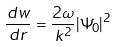<formula> <loc_0><loc_0><loc_500><loc_500>\frac { d w } { d r } = \frac { 2 \omega } { k ^ { 2 } } | \Psi _ { 0 } | ^ { 2 }</formula> 